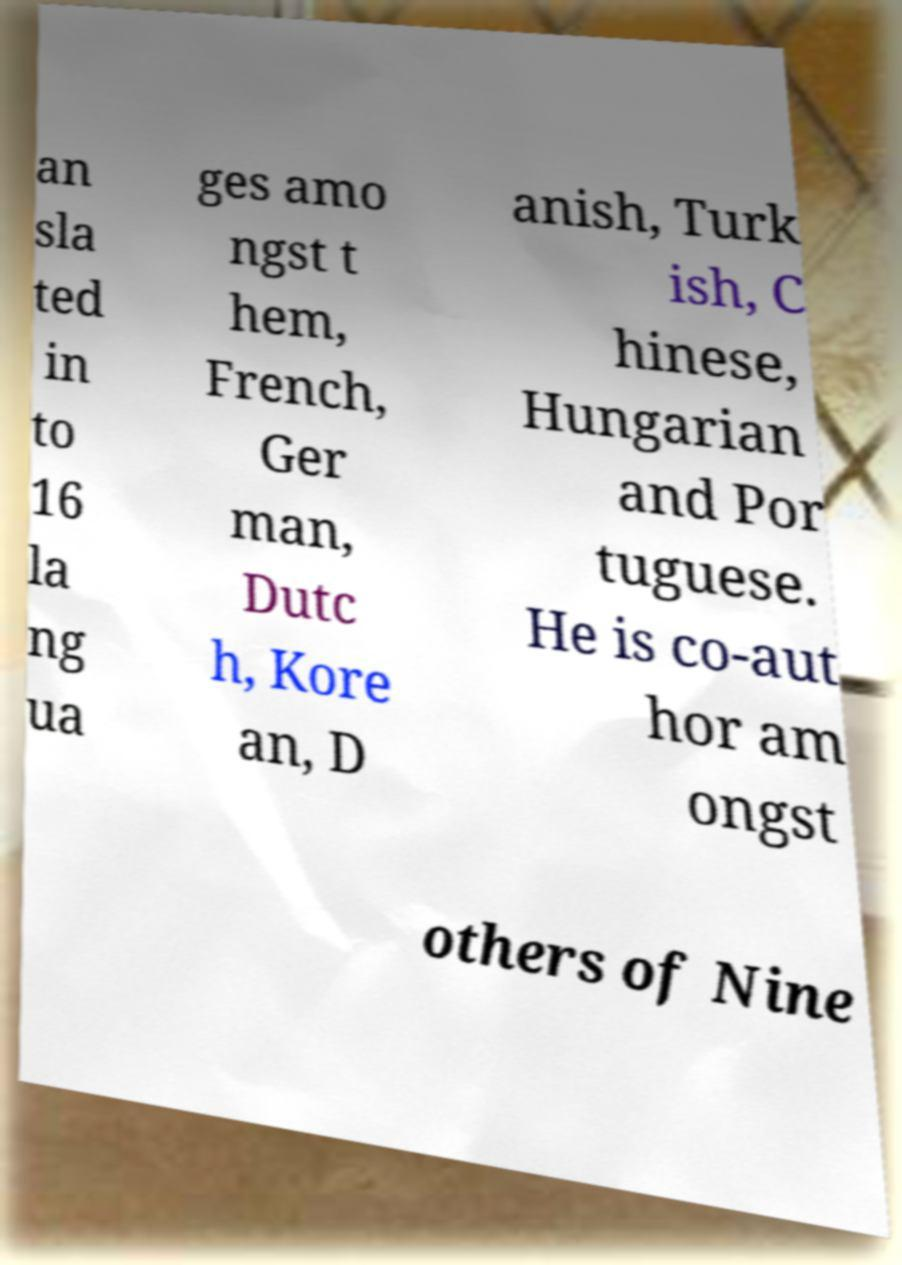There's text embedded in this image that I need extracted. Can you transcribe it verbatim? an sla ted in to 16 la ng ua ges amo ngst t hem, French, Ger man, Dutc h, Kore an, D anish, Turk ish, C hinese, Hungarian and Por tuguese. He is co-aut hor am ongst others of Nine 